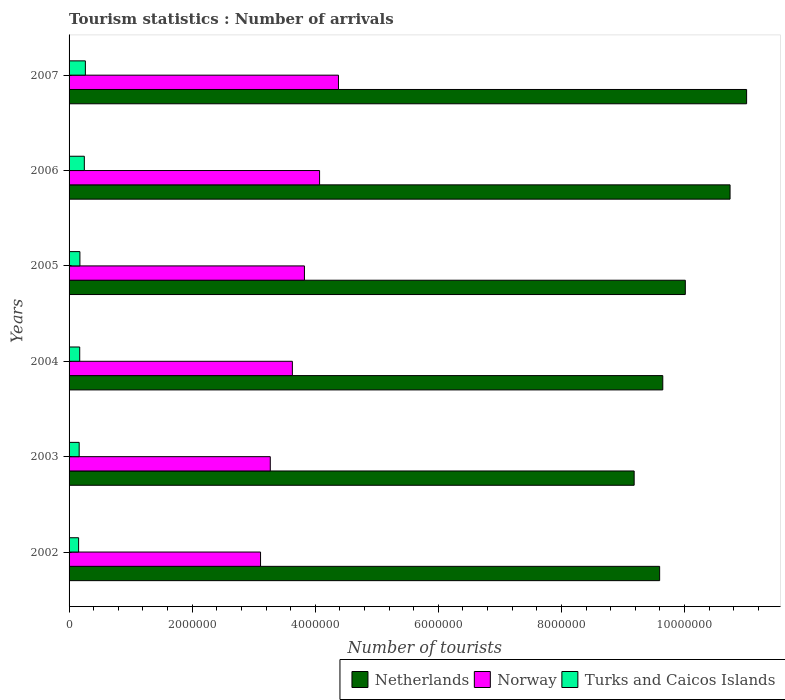How many different coloured bars are there?
Offer a terse response. 3. How many groups of bars are there?
Make the answer very short. 6. How many bars are there on the 4th tick from the top?
Give a very brief answer. 3. How many bars are there on the 2nd tick from the bottom?
Offer a terse response. 3. What is the number of tourist arrivals in Netherlands in 2006?
Your response must be concise. 1.07e+07. Across all years, what is the maximum number of tourist arrivals in Turks and Caicos Islands?
Provide a succinct answer. 2.65e+05. Across all years, what is the minimum number of tourist arrivals in Netherlands?
Ensure brevity in your answer.  9.18e+06. In which year was the number of tourist arrivals in Turks and Caicos Islands maximum?
Offer a terse response. 2007. In which year was the number of tourist arrivals in Turks and Caicos Islands minimum?
Ensure brevity in your answer.  2002. What is the total number of tourist arrivals in Netherlands in the graph?
Ensure brevity in your answer.  6.02e+07. What is the difference between the number of tourist arrivals in Norway in 2002 and that in 2006?
Provide a short and direct response. -9.59e+05. What is the difference between the number of tourist arrivals in Netherlands in 2007 and the number of tourist arrivals in Norway in 2002?
Ensure brevity in your answer.  7.90e+06. What is the average number of tourist arrivals in Turks and Caicos Islands per year?
Your answer should be very brief. 1.97e+05. In the year 2005, what is the difference between the number of tourist arrivals in Turks and Caicos Islands and number of tourist arrivals in Norway?
Provide a succinct answer. -3.65e+06. What is the ratio of the number of tourist arrivals in Turks and Caicos Islands in 2002 to that in 2006?
Offer a terse response. 0.62. What is the difference between the highest and the second highest number of tourist arrivals in Turks and Caicos Islands?
Your response must be concise. 1.70e+04. What is the difference between the highest and the lowest number of tourist arrivals in Norway?
Provide a short and direct response. 1.27e+06. In how many years, is the number of tourist arrivals in Netherlands greater than the average number of tourist arrivals in Netherlands taken over all years?
Offer a very short reply. 2. How many bars are there?
Offer a very short reply. 18. Are all the bars in the graph horizontal?
Provide a succinct answer. Yes. Are the values on the major ticks of X-axis written in scientific E-notation?
Your answer should be compact. No. Does the graph contain any zero values?
Provide a short and direct response. No. Where does the legend appear in the graph?
Offer a very short reply. Bottom right. How many legend labels are there?
Make the answer very short. 3. How are the legend labels stacked?
Provide a succinct answer. Horizontal. What is the title of the graph?
Give a very brief answer. Tourism statistics : Number of arrivals. Does "Oman" appear as one of the legend labels in the graph?
Your answer should be compact. No. What is the label or title of the X-axis?
Provide a short and direct response. Number of tourists. What is the Number of tourists of Netherlands in 2002?
Make the answer very short. 9.60e+06. What is the Number of tourists of Norway in 2002?
Give a very brief answer. 3.11e+06. What is the Number of tourists of Turks and Caicos Islands in 2002?
Offer a very short reply. 1.55e+05. What is the Number of tourists in Netherlands in 2003?
Offer a terse response. 9.18e+06. What is the Number of tourists in Norway in 2003?
Provide a succinct answer. 3.27e+06. What is the Number of tourists in Turks and Caicos Islands in 2003?
Give a very brief answer. 1.64e+05. What is the Number of tourists in Netherlands in 2004?
Your answer should be very brief. 9.65e+06. What is the Number of tourists in Norway in 2004?
Offer a terse response. 3.63e+06. What is the Number of tourists of Turks and Caicos Islands in 2004?
Your answer should be compact. 1.73e+05. What is the Number of tourists in Netherlands in 2005?
Ensure brevity in your answer.  1.00e+07. What is the Number of tourists of Norway in 2005?
Your answer should be very brief. 3.82e+06. What is the Number of tourists of Turks and Caicos Islands in 2005?
Offer a terse response. 1.76e+05. What is the Number of tourists in Netherlands in 2006?
Your answer should be very brief. 1.07e+07. What is the Number of tourists of Norway in 2006?
Make the answer very short. 4.07e+06. What is the Number of tourists of Turks and Caicos Islands in 2006?
Give a very brief answer. 2.48e+05. What is the Number of tourists in Netherlands in 2007?
Your answer should be very brief. 1.10e+07. What is the Number of tourists in Norway in 2007?
Your response must be concise. 4.38e+06. What is the Number of tourists in Turks and Caicos Islands in 2007?
Your answer should be very brief. 2.65e+05. Across all years, what is the maximum Number of tourists in Netherlands?
Offer a terse response. 1.10e+07. Across all years, what is the maximum Number of tourists in Norway?
Your answer should be compact. 4.38e+06. Across all years, what is the maximum Number of tourists of Turks and Caicos Islands?
Give a very brief answer. 2.65e+05. Across all years, what is the minimum Number of tourists in Netherlands?
Your answer should be compact. 9.18e+06. Across all years, what is the minimum Number of tourists of Norway?
Provide a succinct answer. 3.11e+06. Across all years, what is the minimum Number of tourists in Turks and Caicos Islands?
Make the answer very short. 1.55e+05. What is the total Number of tourists in Netherlands in the graph?
Make the answer very short. 6.02e+07. What is the total Number of tourists of Norway in the graph?
Offer a terse response. 2.23e+07. What is the total Number of tourists of Turks and Caicos Islands in the graph?
Your answer should be compact. 1.18e+06. What is the difference between the Number of tourists of Netherlands in 2002 and that in 2003?
Your answer should be very brief. 4.14e+05. What is the difference between the Number of tourists of Norway in 2002 and that in 2003?
Offer a very short reply. -1.58e+05. What is the difference between the Number of tourists of Turks and Caicos Islands in 2002 and that in 2003?
Give a very brief answer. -9000. What is the difference between the Number of tourists in Netherlands in 2002 and that in 2004?
Keep it short and to the point. -5.10e+04. What is the difference between the Number of tourists in Norway in 2002 and that in 2004?
Your answer should be very brief. -5.17e+05. What is the difference between the Number of tourists of Turks and Caicos Islands in 2002 and that in 2004?
Ensure brevity in your answer.  -1.80e+04. What is the difference between the Number of tourists in Netherlands in 2002 and that in 2005?
Give a very brief answer. -4.17e+05. What is the difference between the Number of tourists of Norway in 2002 and that in 2005?
Your response must be concise. -7.13e+05. What is the difference between the Number of tourists in Turks and Caicos Islands in 2002 and that in 2005?
Your response must be concise. -2.10e+04. What is the difference between the Number of tourists in Netherlands in 2002 and that in 2006?
Offer a very short reply. -1.14e+06. What is the difference between the Number of tourists in Norway in 2002 and that in 2006?
Provide a short and direct response. -9.59e+05. What is the difference between the Number of tourists of Turks and Caicos Islands in 2002 and that in 2006?
Ensure brevity in your answer.  -9.30e+04. What is the difference between the Number of tourists of Netherlands in 2002 and that in 2007?
Your response must be concise. -1.41e+06. What is the difference between the Number of tourists in Norway in 2002 and that in 2007?
Your response must be concise. -1.27e+06. What is the difference between the Number of tourists of Netherlands in 2003 and that in 2004?
Offer a very short reply. -4.65e+05. What is the difference between the Number of tourists in Norway in 2003 and that in 2004?
Provide a short and direct response. -3.59e+05. What is the difference between the Number of tourists of Turks and Caicos Islands in 2003 and that in 2004?
Make the answer very short. -9000. What is the difference between the Number of tourists in Netherlands in 2003 and that in 2005?
Provide a succinct answer. -8.31e+05. What is the difference between the Number of tourists of Norway in 2003 and that in 2005?
Provide a short and direct response. -5.55e+05. What is the difference between the Number of tourists in Turks and Caicos Islands in 2003 and that in 2005?
Offer a terse response. -1.20e+04. What is the difference between the Number of tourists of Netherlands in 2003 and that in 2006?
Your answer should be very brief. -1.56e+06. What is the difference between the Number of tourists in Norway in 2003 and that in 2006?
Give a very brief answer. -8.01e+05. What is the difference between the Number of tourists in Turks and Caicos Islands in 2003 and that in 2006?
Offer a terse response. -8.40e+04. What is the difference between the Number of tourists in Netherlands in 2003 and that in 2007?
Provide a short and direct response. -1.83e+06. What is the difference between the Number of tourists of Norway in 2003 and that in 2007?
Your answer should be very brief. -1.11e+06. What is the difference between the Number of tourists of Turks and Caicos Islands in 2003 and that in 2007?
Give a very brief answer. -1.01e+05. What is the difference between the Number of tourists in Netherlands in 2004 and that in 2005?
Provide a succinct answer. -3.66e+05. What is the difference between the Number of tourists in Norway in 2004 and that in 2005?
Your response must be concise. -1.96e+05. What is the difference between the Number of tourists in Turks and Caicos Islands in 2004 and that in 2005?
Your answer should be very brief. -3000. What is the difference between the Number of tourists of Netherlands in 2004 and that in 2006?
Offer a terse response. -1.09e+06. What is the difference between the Number of tourists of Norway in 2004 and that in 2006?
Your response must be concise. -4.42e+05. What is the difference between the Number of tourists in Turks and Caicos Islands in 2004 and that in 2006?
Keep it short and to the point. -7.50e+04. What is the difference between the Number of tourists of Netherlands in 2004 and that in 2007?
Make the answer very short. -1.36e+06. What is the difference between the Number of tourists in Norway in 2004 and that in 2007?
Keep it short and to the point. -7.49e+05. What is the difference between the Number of tourists in Turks and Caicos Islands in 2004 and that in 2007?
Offer a terse response. -9.20e+04. What is the difference between the Number of tourists of Netherlands in 2005 and that in 2006?
Your answer should be very brief. -7.27e+05. What is the difference between the Number of tourists of Norway in 2005 and that in 2006?
Offer a terse response. -2.46e+05. What is the difference between the Number of tourists in Turks and Caicos Islands in 2005 and that in 2006?
Offer a terse response. -7.20e+04. What is the difference between the Number of tourists in Netherlands in 2005 and that in 2007?
Your answer should be very brief. -9.96e+05. What is the difference between the Number of tourists of Norway in 2005 and that in 2007?
Ensure brevity in your answer.  -5.53e+05. What is the difference between the Number of tourists of Turks and Caicos Islands in 2005 and that in 2007?
Offer a very short reply. -8.90e+04. What is the difference between the Number of tourists of Netherlands in 2006 and that in 2007?
Provide a short and direct response. -2.69e+05. What is the difference between the Number of tourists in Norway in 2006 and that in 2007?
Your answer should be very brief. -3.07e+05. What is the difference between the Number of tourists of Turks and Caicos Islands in 2006 and that in 2007?
Provide a short and direct response. -1.70e+04. What is the difference between the Number of tourists in Netherlands in 2002 and the Number of tourists in Norway in 2003?
Give a very brief answer. 6.33e+06. What is the difference between the Number of tourists of Netherlands in 2002 and the Number of tourists of Turks and Caicos Islands in 2003?
Provide a succinct answer. 9.43e+06. What is the difference between the Number of tourists of Norway in 2002 and the Number of tourists of Turks and Caicos Islands in 2003?
Offer a terse response. 2.95e+06. What is the difference between the Number of tourists in Netherlands in 2002 and the Number of tourists in Norway in 2004?
Your answer should be compact. 5.97e+06. What is the difference between the Number of tourists in Netherlands in 2002 and the Number of tourists in Turks and Caicos Islands in 2004?
Offer a very short reply. 9.42e+06. What is the difference between the Number of tourists of Norway in 2002 and the Number of tourists of Turks and Caicos Islands in 2004?
Your answer should be very brief. 2.94e+06. What is the difference between the Number of tourists in Netherlands in 2002 and the Number of tourists in Norway in 2005?
Provide a succinct answer. 5.77e+06. What is the difference between the Number of tourists in Netherlands in 2002 and the Number of tourists in Turks and Caicos Islands in 2005?
Provide a short and direct response. 9.42e+06. What is the difference between the Number of tourists of Norway in 2002 and the Number of tourists of Turks and Caicos Islands in 2005?
Your answer should be very brief. 2.94e+06. What is the difference between the Number of tourists in Netherlands in 2002 and the Number of tourists in Norway in 2006?
Keep it short and to the point. 5.52e+06. What is the difference between the Number of tourists of Netherlands in 2002 and the Number of tourists of Turks and Caicos Islands in 2006?
Give a very brief answer. 9.35e+06. What is the difference between the Number of tourists in Norway in 2002 and the Number of tourists in Turks and Caicos Islands in 2006?
Offer a terse response. 2.86e+06. What is the difference between the Number of tourists in Netherlands in 2002 and the Number of tourists in Norway in 2007?
Give a very brief answer. 5.22e+06. What is the difference between the Number of tourists in Netherlands in 2002 and the Number of tourists in Turks and Caicos Islands in 2007?
Offer a terse response. 9.33e+06. What is the difference between the Number of tourists in Norway in 2002 and the Number of tourists in Turks and Caicos Islands in 2007?
Keep it short and to the point. 2.85e+06. What is the difference between the Number of tourists in Netherlands in 2003 and the Number of tourists in Norway in 2004?
Give a very brief answer. 5.55e+06. What is the difference between the Number of tourists in Netherlands in 2003 and the Number of tourists in Turks and Caicos Islands in 2004?
Provide a succinct answer. 9.01e+06. What is the difference between the Number of tourists of Norway in 2003 and the Number of tourists of Turks and Caicos Islands in 2004?
Give a very brief answer. 3.10e+06. What is the difference between the Number of tourists in Netherlands in 2003 and the Number of tourists in Norway in 2005?
Offer a terse response. 5.36e+06. What is the difference between the Number of tourists in Netherlands in 2003 and the Number of tourists in Turks and Caicos Islands in 2005?
Offer a very short reply. 9.00e+06. What is the difference between the Number of tourists of Norway in 2003 and the Number of tourists of Turks and Caicos Islands in 2005?
Provide a succinct answer. 3.09e+06. What is the difference between the Number of tourists of Netherlands in 2003 and the Number of tourists of Norway in 2006?
Ensure brevity in your answer.  5.11e+06. What is the difference between the Number of tourists of Netherlands in 2003 and the Number of tourists of Turks and Caicos Islands in 2006?
Make the answer very short. 8.93e+06. What is the difference between the Number of tourists of Norway in 2003 and the Number of tourists of Turks and Caicos Islands in 2006?
Give a very brief answer. 3.02e+06. What is the difference between the Number of tourists of Netherlands in 2003 and the Number of tourists of Norway in 2007?
Provide a short and direct response. 4.80e+06. What is the difference between the Number of tourists in Netherlands in 2003 and the Number of tourists in Turks and Caicos Islands in 2007?
Offer a very short reply. 8.92e+06. What is the difference between the Number of tourists in Norway in 2003 and the Number of tourists in Turks and Caicos Islands in 2007?
Ensure brevity in your answer.  3.00e+06. What is the difference between the Number of tourists of Netherlands in 2004 and the Number of tourists of Norway in 2005?
Make the answer very short. 5.82e+06. What is the difference between the Number of tourists of Netherlands in 2004 and the Number of tourists of Turks and Caicos Islands in 2005?
Offer a terse response. 9.47e+06. What is the difference between the Number of tourists of Norway in 2004 and the Number of tourists of Turks and Caicos Islands in 2005?
Your response must be concise. 3.45e+06. What is the difference between the Number of tourists in Netherlands in 2004 and the Number of tourists in Norway in 2006?
Offer a very short reply. 5.58e+06. What is the difference between the Number of tourists of Netherlands in 2004 and the Number of tourists of Turks and Caicos Islands in 2006?
Provide a short and direct response. 9.40e+06. What is the difference between the Number of tourists of Norway in 2004 and the Number of tourists of Turks and Caicos Islands in 2006?
Make the answer very short. 3.38e+06. What is the difference between the Number of tourists in Netherlands in 2004 and the Number of tourists in Norway in 2007?
Provide a succinct answer. 5.27e+06. What is the difference between the Number of tourists of Netherlands in 2004 and the Number of tourists of Turks and Caicos Islands in 2007?
Offer a terse response. 9.38e+06. What is the difference between the Number of tourists in Norway in 2004 and the Number of tourists in Turks and Caicos Islands in 2007?
Provide a short and direct response. 3.36e+06. What is the difference between the Number of tourists of Netherlands in 2005 and the Number of tourists of Norway in 2006?
Give a very brief answer. 5.94e+06. What is the difference between the Number of tourists in Netherlands in 2005 and the Number of tourists in Turks and Caicos Islands in 2006?
Your response must be concise. 9.76e+06. What is the difference between the Number of tourists in Norway in 2005 and the Number of tourists in Turks and Caicos Islands in 2006?
Your response must be concise. 3.58e+06. What is the difference between the Number of tourists of Netherlands in 2005 and the Number of tourists of Norway in 2007?
Ensure brevity in your answer.  5.64e+06. What is the difference between the Number of tourists in Netherlands in 2005 and the Number of tourists in Turks and Caicos Islands in 2007?
Provide a short and direct response. 9.75e+06. What is the difference between the Number of tourists of Norway in 2005 and the Number of tourists of Turks and Caicos Islands in 2007?
Your answer should be compact. 3.56e+06. What is the difference between the Number of tourists of Netherlands in 2006 and the Number of tourists of Norway in 2007?
Your answer should be compact. 6.36e+06. What is the difference between the Number of tourists of Netherlands in 2006 and the Number of tourists of Turks and Caicos Islands in 2007?
Your answer should be very brief. 1.05e+07. What is the difference between the Number of tourists in Norway in 2006 and the Number of tourists in Turks and Caicos Islands in 2007?
Make the answer very short. 3.80e+06. What is the average Number of tourists of Netherlands per year?
Offer a terse response. 1.00e+07. What is the average Number of tourists of Norway per year?
Offer a very short reply. 3.71e+06. What is the average Number of tourists in Turks and Caicos Islands per year?
Provide a short and direct response. 1.97e+05. In the year 2002, what is the difference between the Number of tourists of Netherlands and Number of tourists of Norway?
Offer a terse response. 6.48e+06. In the year 2002, what is the difference between the Number of tourists in Netherlands and Number of tourists in Turks and Caicos Islands?
Keep it short and to the point. 9.44e+06. In the year 2002, what is the difference between the Number of tourists of Norway and Number of tourists of Turks and Caicos Islands?
Ensure brevity in your answer.  2.96e+06. In the year 2003, what is the difference between the Number of tourists of Netherlands and Number of tourists of Norway?
Offer a very short reply. 5.91e+06. In the year 2003, what is the difference between the Number of tourists of Netherlands and Number of tourists of Turks and Caicos Islands?
Your answer should be compact. 9.02e+06. In the year 2003, what is the difference between the Number of tourists in Norway and Number of tourists in Turks and Caicos Islands?
Ensure brevity in your answer.  3.10e+06. In the year 2004, what is the difference between the Number of tourists in Netherlands and Number of tourists in Norway?
Give a very brief answer. 6.02e+06. In the year 2004, what is the difference between the Number of tourists of Netherlands and Number of tourists of Turks and Caicos Islands?
Ensure brevity in your answer.  9.47e+06. In the year 2004, what is the difference between the Number of tourists of Norway and Number of tourists of Turks and Caicos Islands?
Offer a very short reply. 3.46e+06. In the year 2005, what is the difference between the Number of tourists in Netherlands and Number of tourists in Norway?
Your answer should be compact. 6.19e+06. In the year 2005, what is the difference between the Number of tourists of Netherlands and Number of tourists of Turks and Caicos Islands?
Make the answer very short. 9.84e+06. In the year 2005, what is the difference between the Number of tourists of Norway and Number of tourists of Turks and Caicos Islands?
Your answer should be compact. 3.65e+06. In the year 2006, what is the difference between the Number of tourists of Netherlands and Number of tourists of Norway?
Your answer should be very brief. 6.67e+06. In the year 2006, what is the difference between the Number of tourists in Netherlands and Number of tourists in Turks and Caicos Islands?
Ensure brevity in your answer.  1.05e+07. In the year 2006, what is the difference between the Number of tourists of Norway and Number of tourists of Turks and Caicos Islands?
Ensure brevity in your answer.  3.82e+06. In the year 2007, what is the difference between the Number of tourists in Netherlands and Number of tourists in Norway?
Your response must be concise. 6.63e+06. In the year 2007, what is the difference between the Number of tourists in Netherlands and Number of tourists in Turks and Caicos Islands?
Make the answer very short. 1.07e+07. In the year 2007, what is the difference between the Number of tourists in Norway and Number of tourists in Turks and Caicos Islands?
Offer a terse response. 4.11e+06. What is the ratio of the Number of tourists of Netherlands in 2002 to that in 2003?
Give a very brief answer. 1.05. What is the ratio of the Number of tourists in Norway in 2002 to that in 2003?
Ensure brevity in your answer.  0.95. What is the ratio of the Number of tourists in Turks and Caicos Islands in 2002 to that in 2003?
Provide a short and direct response. 0.95. What is the ratio of the Number of tourists in Netherlands in 2002 to that in 2004?
Offer a very short reply. 0.99. What is the ratio of the Number of tourists of Norway in 2002 to that in 2004?
Make the answer very short. 0.86. What is the ratio of the Number of tourists in Turks and Caicos Islands in 2002 to that in 2004?
Ensure brevity in your answer.  0.9. What is the ratio of the Number of tourists in Norway in 2002 to that in 2005?
Make the answer very short. 0.81. What is the ratio of the Number of tourists of Turks and Caicos Islands in 2002 to that in 2005?
Provide a short and direct response. 0.88. What is the ratio of the Number of tourists in Netherlands in 2002 to that in 2006?
Your answer should be very brief. 0.89. What is the ratio of the Number of tourists of Norway in 2002 to that in 2006?
Your answer should be compact. 0.76. What is the ratio of the Number of tourists of Turks and Caicos Islands in 2002 to that in 2006?
Give a very brief answer. 0.62. What is the ratio of the Number of tourists in Netherlands in 2002 to that in 2007?
Your answer should be very brief. 0.87. What is the ratio of the Number of tourists in Norway in 2002 to that in 2007?
Provide a succinct answer. 0.71. What is the ratio of the Number of tourists of Turks and Caicos Islands in 2002 to that in 2007?
Offer a very short reply. 0.58. What is the ratio of the Number of tourists of Netherlands in 2003 to that in 2004?
Your response must be concise. 0.95. What is the ratio of the Number of tourists in Norway in 2003 to that in 2004?
Give a very brief answer. 0.9. What is the ratio of the Number of tourists of Turks and Caicos Islands in 2003 to that in 2004?
Your answer should be compact. 0.95. What is the ratio of the Number of tourists in Netherlands in 2003 to that in 2005?
Make the answer very short. 0.92. What is the ratio of the Number of tourists of Norway in 2003 to that in 2005?
Make the answer very short. 0.85. What is the ratio of the Number of tourists in Turks and Caicos Islands in 2003 to that in 2005?
Give a very brief answer. 0.93. What is the ratio of the Number of tourists of Netherlands in 2003 to that in 2006?
Offer a very short reply. 0.85. What is the ratio of the Number of tourists in Norway in 2003 to that in 2006?
Ensure brevity in your answer.  0.8. What is the ratio of the Number of tourists of Turks and Caicos Islands in 2003 to that in 2006?
Provide a short and direct response. 0.66. What is the ratio of the Number of tourists of Netherlands in 2003 to that in 2007?
Offer a terse response. 0.83. What is the ratio of the Number of tourists in Norway in 2003 to that in 2007?
Provide a succinct answer. 0.75. What is the ratio of the Number of tourists of Turks and Caicos Islands in 2003 to that in 2007?
Keep it short and to the point. 0.62. What is the ratio of the Number of tourists in Netherlands in 2004 to that in 2005?
Ensure brevity in your answer.  0.96. What is the ratio of the Number of tourists in Norway in 2004 to that in 2005?
Your answer should be compact. 0.95. What is the ratio of the Number of tourists of Netherlands in 2004 to that in 2006?
Your answer should be compact. 0.9. What is the ratio of the Number of tourists of Norway in 2004 to that in 2006?
Offer a very short reply. 0.89. What is the ratio of the Number of tourists of Turks and Caicos Islands in 2004 to that in 2006?
Make the answer very short. 0.7. What is the ratio of the Number of tourists of Netherlands in 2004 to that in 2007?
Your answer should be compact. 0.88. What is the ratio of the Number of tourists of Norway in 2004 to that in 2007?
Your answer should be compact. 0.83. What is the ratio of the Number of tourists in Turks and Caicos Islands in 2004 to that in 2007?
Keep it short and to the point. 0.65. What is the ratio of the Number of tourists in Netherlands in 2005 to that in 2006?
Ensure brevity in your answer.  0.93. What is the ratio of the Number of tourists in Norway in 2005 to that in 2006?
Your response must be concise. 0.94. What is the ratio of the Number of tourists of Turks and Caicos Islands in 2005 to that in 2006?
Provide a succinct answer. 0.71. What is the ratio of the Number of tourists in Netherlands in 2005 to that in 2007?
Your answer should be compact. 0.91. What is the ratio of the Number of tourists in Norway in 2005 to that in 2007?
Your response must be concise. 0.87. What is the ratio of the Number of tourists in Turks and Caicos Islands in 2005 to that in 2007?
Your answer should be compact. 0.66. What is the ratio of the Number of tourists in Netherlands in 2006 to that in 2007?
Provide a short and direct response. 0.98. What is the ratio of the Number of tourists of Norway in 2006 to that in 2007?
Ensure brevity in your answer.  0.93. What is the ratio of the Number of tourists in Turks and Caicos Islands in 2006 to that in 2007?
Provide a succinct answer. 0.94. What is the difference between the highest and the second highest Number of tourists of Netherlands?
Offer a terse response. 2.69e+05. What is the difference between the highest and the second highest Number of tourists of Norway?
Provide a succinct answer. 3.07e+05. What is the difference between the highest and the second highest Number of tourists in Turks and Caicos Islands?
Offer a terse response. 1.70e+04. What is the difference between the highest and the lowest Number of tourists of Netherlands?
Your answer should be very brief. 1.83e+06. What is the difference between the highest and the lowest Number of tourists in Norway?
Your answer should be compact. 1.27e+06. 